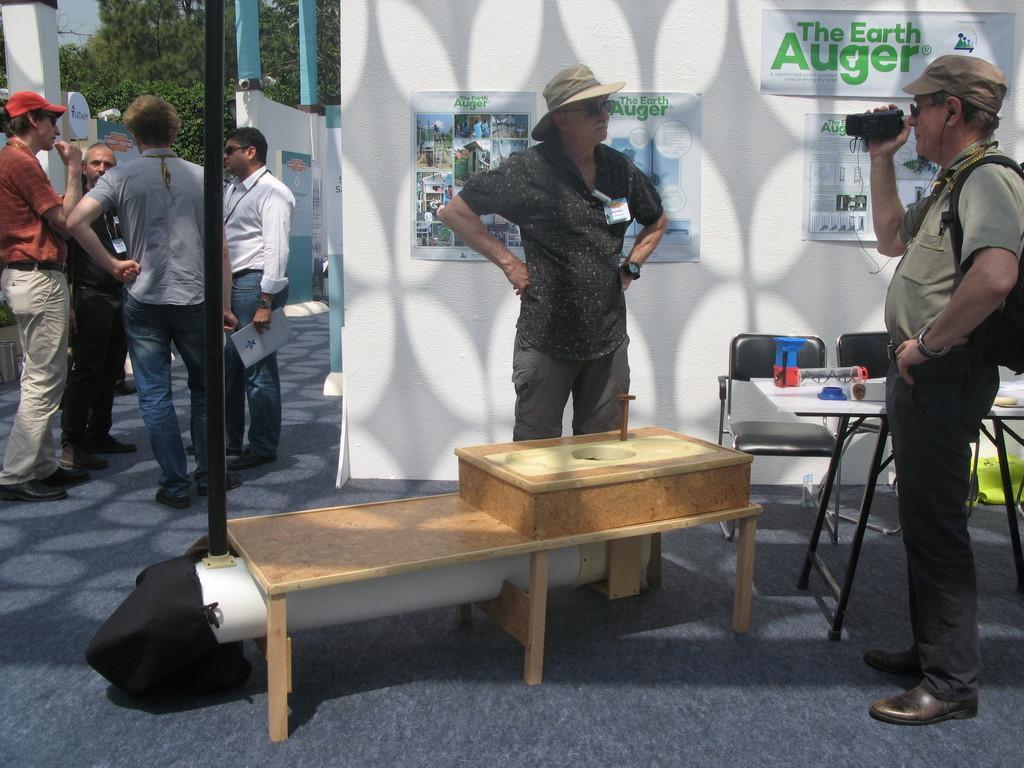Please provide a concise description of this image. On the background we can see trees. This is a wall in white color, we can see few posts on it. Here we can see few persons standing and discussing something. This man is standing in front of a table and recording. These are chairs and on the table we can see few items. This is also a table. 